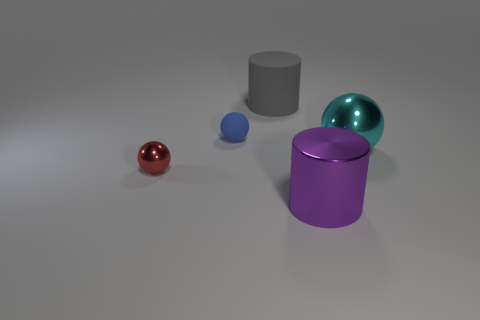Add 1 small red metallic balls. How many objects exist? 6 Subtract all balls. How many objects are left? 2 Subtract 0 yellow spheres. How many objects are left? 5 Subtract all gray rubber objects. Subtract all big gray things. How many objects are left? 3 Add 5 purple metallic cylinders. How many purple metallic cylinders are left? 6 Add 5 big spheres. How many big spheres exist? 6 